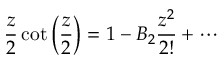Convert formula to latex. <formula><loc_0><loc_0><loc_500><loc_500>{ \frac { z } { 2 } } \cot \left ( { \frac { z } { 2 } } \right ) = 1 - B _ { 2 } { \frac { z ^ { 2 } } { 2 ! } } + \cdots</formula> 